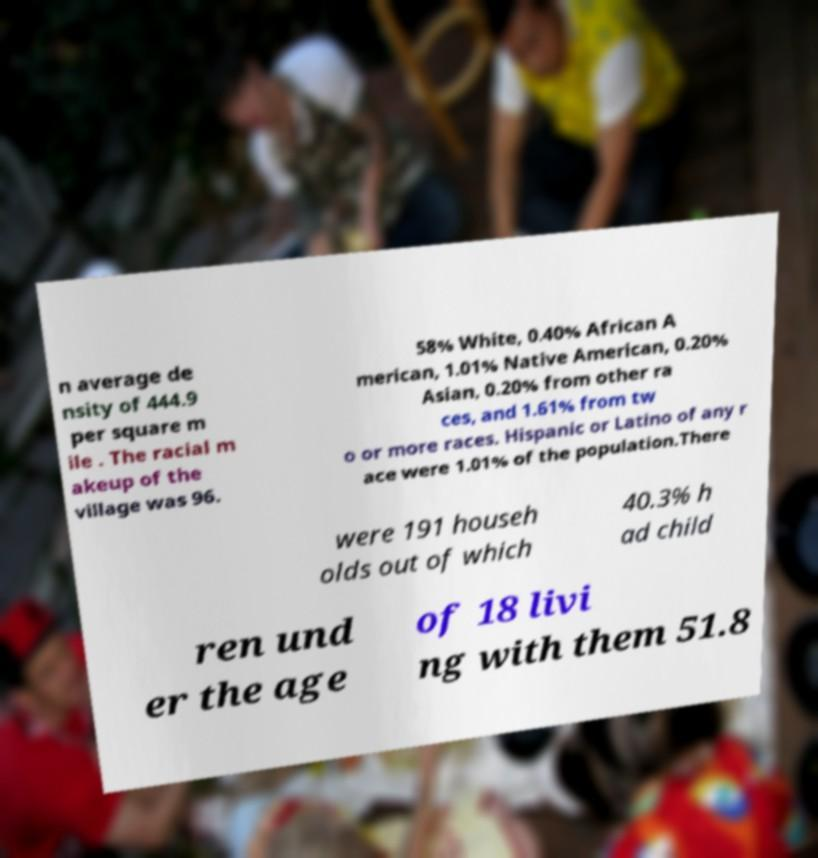Can you read and provide the text displayed in the image?This photo seems to have some interesting text. Can you extract and type it out for me? n average de nsity of 444.9 per square m ile . The racial m akeup of the village was 96. 58% White, 0.40% African A merican, 1.01% Native American, 0.20% Asian, 0.20% from other ra ces, and 1.61% from tw o or more races. Hispanic or Latino of any r ace were 1.01% of the population.There were 191 househ olds out of which 40.3% h ad child ren und er the age of 18 livi ng with them 51.8 